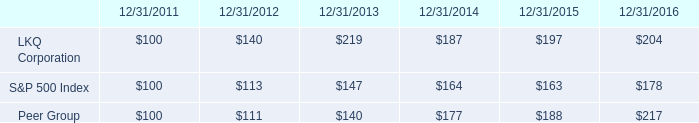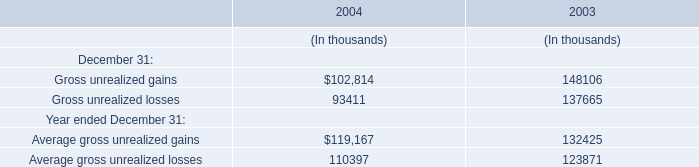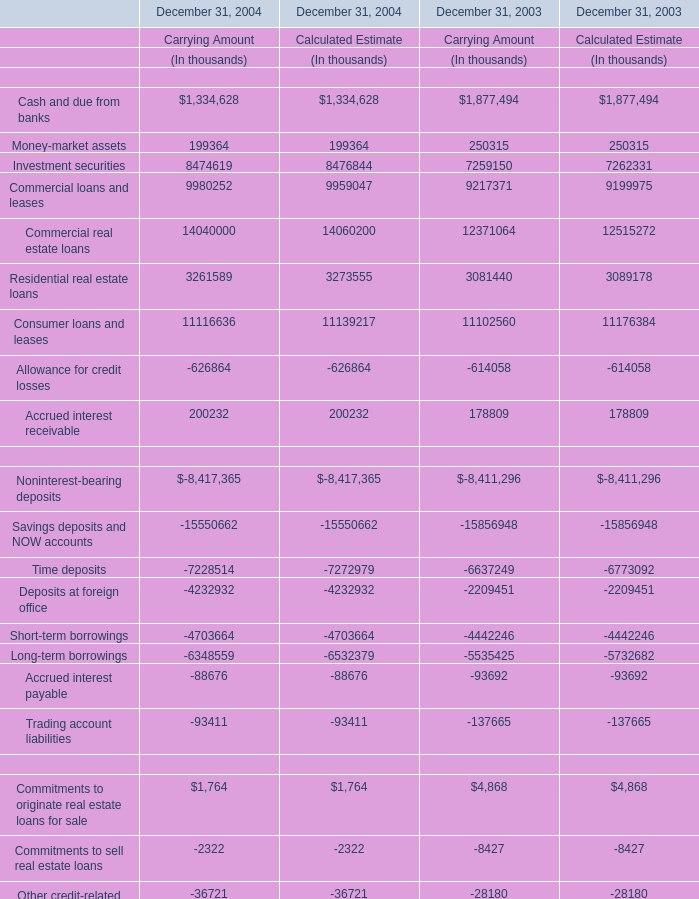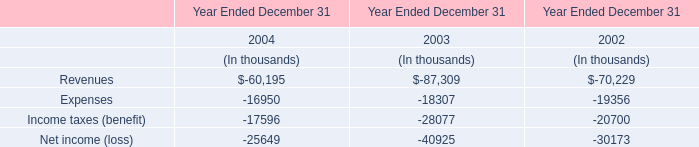What do all financial assets in carrying amount sum up, excluding those negative ones in 2004? (in thousand) 
Computations: (((((((1334628 + 199364) + 8474619) + 9980252) + 14040000) + 3261589) + 11116636) + 200232)
Answer: 48607320.0. 